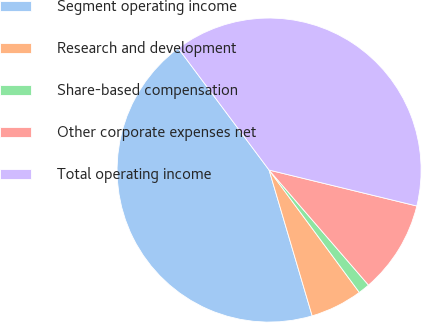<chart> <loc_0><loc_0><loc_500><loc_500><pie_chart><fcel>Segment operating income<fcel>Research and development<fcel>Share-based compensation<fcel>Other corporate expenses net<fcel>Total operating income<nl><fcel>44.37%<fcel>5.54%<fcel>1.23%<fcel>9.86%<fcel>39.0%<nl></chart> 